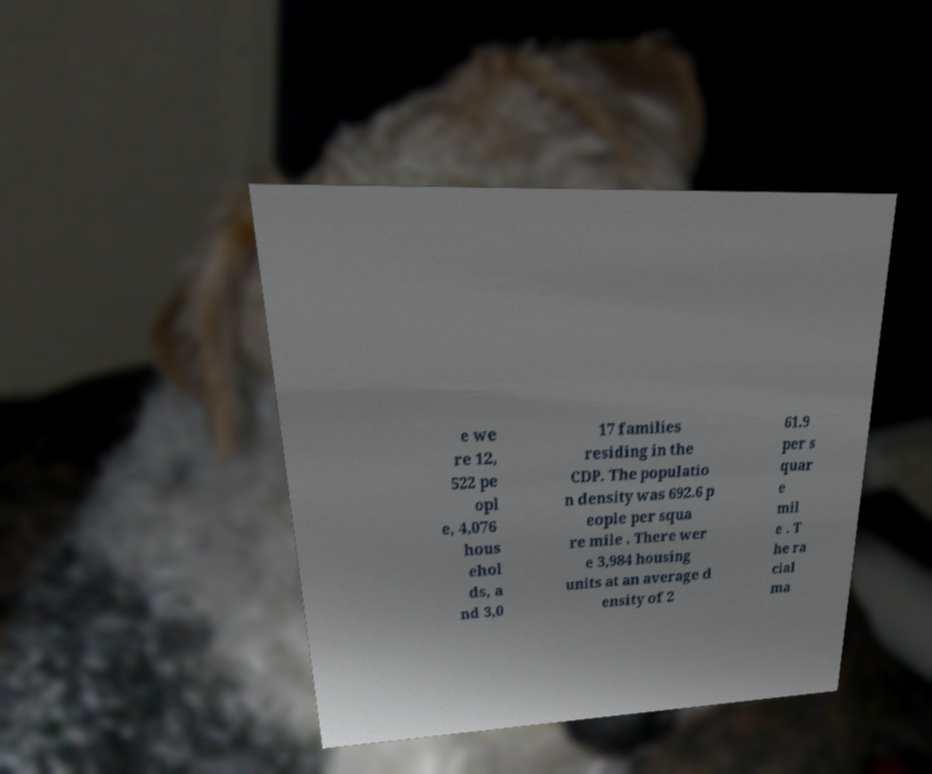Can you accurately transcribe the text from the provided image for me? e we re 12, 522 pe opl e, 4,076 hous ehol ds, a nd 3,0 17 families residing in the CDP. The populatio n density was 692.6 p eople per squa re mile . There wer e 3,984 housing units at an average d ensity of 2 61.9 per s quar e mil e . T he ra cial ma 